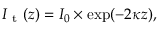<formula> <loc_0><loc_0><loc_500><loc_500>I _ { t } ( z ) = I _ { 0 } \times \exp ( - 2 \kappa z ) ,</formula> 